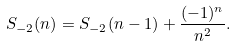Convert formula to latex. <formula><loc_0><loc_0><loc_500><loc_500>S _ { - 2 } ( n ) = S _ { - 2 } ( n - 1 ) + \frac { ( - 1 ) ^ { n } } { n ^ { 2 } } .</formula> 